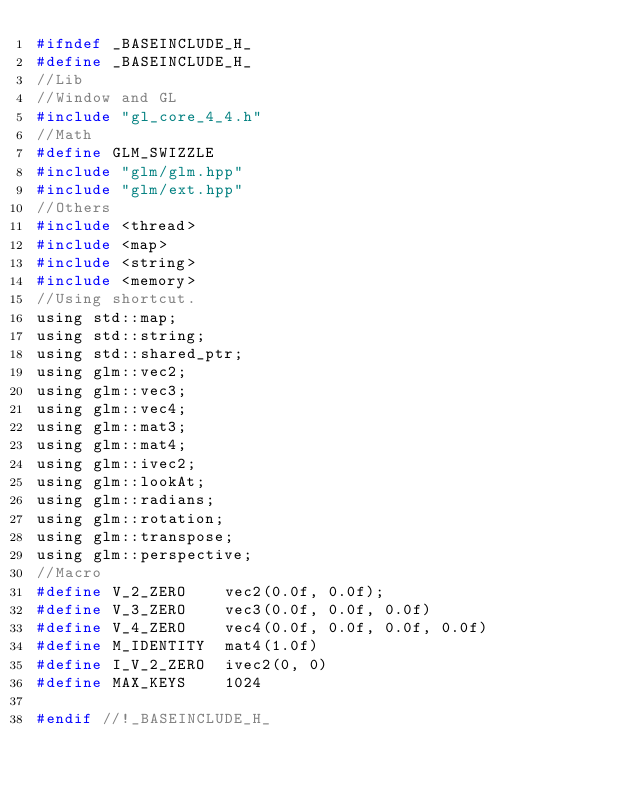Convert code to text. <code><loc_0><loc_0><loc_500><loc_500><_C_>#ifndef _BASEINCLUDE_H_
#define _BASEINCLUDE_H_
//Lib
//Window and GL
#include "gl_core_4_4.h"
//Math
#define GLM_SWIZZLE
#include "glm/glm.hpp"
#include "glm/ext.hpp"
//Others
#include <thread>
#include <map>
#include <string>
#include <memory>
//Using shortcut.
using std::map;
using std::string;
using std::shared_ptr;
using glm::vec2;
using glm::vec3;
using glm::vec4;
using glm::mat3;
using glm::mat4;
using glm::ivec2;
using glm::lookAt;
using glm::radians;
using glm::rotation;
using glm::transpose;
using glm::perspective;
//Macro
#define V_2_ZERO	vec2(0.0f, 0.0f);
#define V_3_ZERO	vec3(0.0f, 0.0f, 0.0f)
#define V_4_ZERO	vec4(0.0f, 0.0f, 0.0f, 0.0f)
#define M_IDENTITY	mat4(1.0f)
#define I_V_2_ZERO	ivec2(0, 0)
#define MAX_KEYS	1024

#endif //!_BASEINCLUDE_H_</code> 